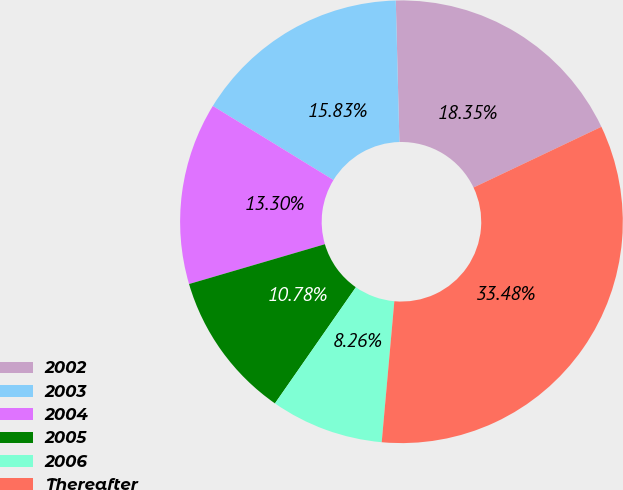Convert chart to OTSL. <chart><loc_0><loc_0><loc_500><loc_500><pie_chart><fcel>2002<fcel>2003<fcel>2004<fcel>2005<fcel>2006<fcel>Thereafter<nl><fcel>18.35%<fcel>15.83%<fcel>13.3%<fcel>10.78%<fcel>8.26%<fcel>33.48%<nl></chart> 